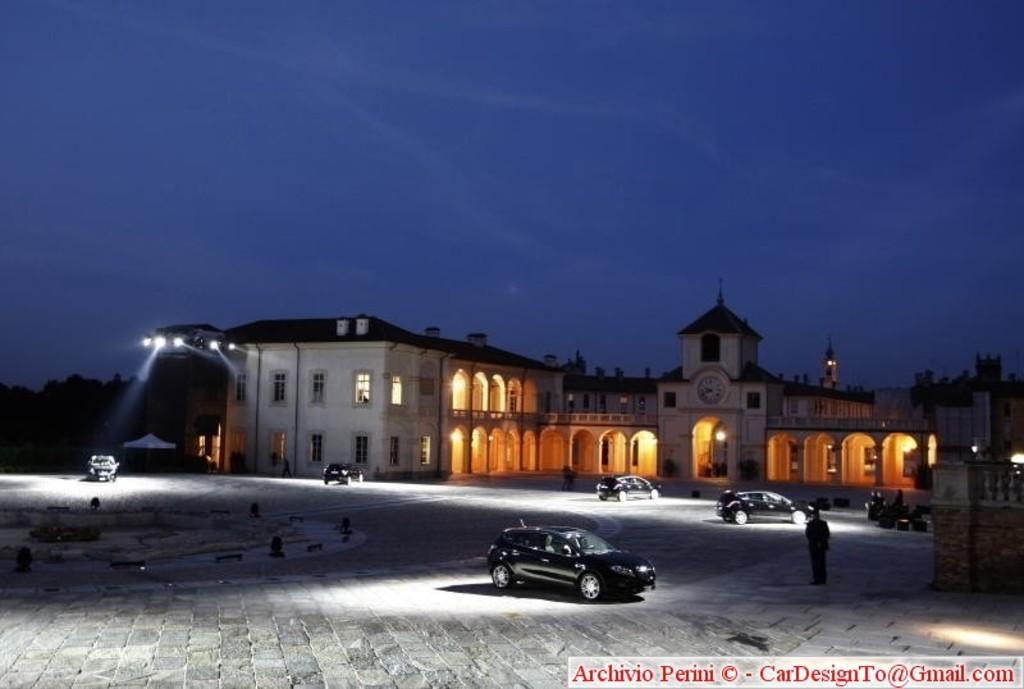Can you describe this image briefly? In this image, there are pillars, walls, building, lights, windows, pipes and railings. At the bottom of the image, we can see vehicles and person are on the path. In the bottom right corner, there is a watermark in the image. In the background, there are trees and the sky. 